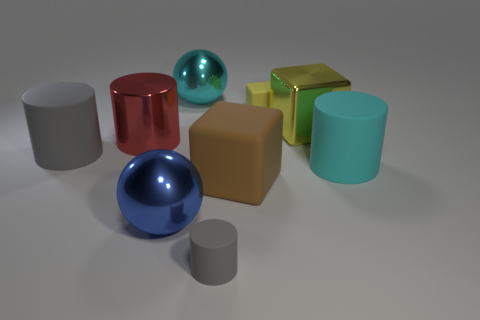Is the number of big gray things to the right of the large gray matte cylinder less than the number of tiny red balls?
Offer a very short reply. No. What number of shiny balls are there?
Give a very brief answer. 2. How many large metallic things are the same color as the small cube?
Offer a terse response. 1. Is the shape of the brown rubber thing the same as the yellow rubber object?
Offer a terse response. Yes. How big is the shiny ball that is in front of the big metallic ball that is behind the large gray cylinder?
Your answer should be very brief. Large. Are there any matte blocks that have the same size as the blue sphere?
Make the answer very short. Yes. There is a gray cylinder in front of the cyan rubber cylinder; is it the same size as the matte thing that is on the right side of the tiny yellow rubber cube?
Keep it short and to the point. No. What is the shape of the large cyan object to the left of the large cyan object in front of the large yellow metal cube?
Give a very brief answer. Sphere. What number of big spheres are behind the red shiny cylinder?
Provide a short and direct response. 1. There is another block that is made of the same material as the small cube; what is its color?
Your response must be concise. Brown. 